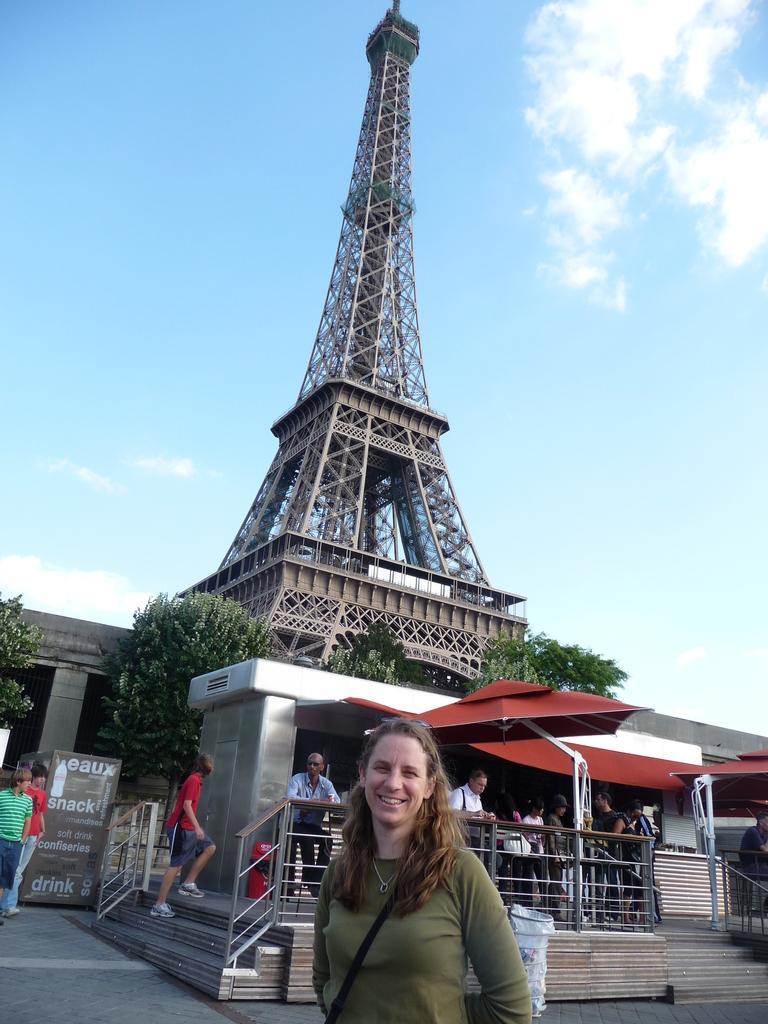Describe this image in one or two sentences. In the foreground we can see a woman and she is smiling. Here we can see a few people. In the background, we can see the Eiffel tower. Here we can see the trees. This is a sky with clouds. 